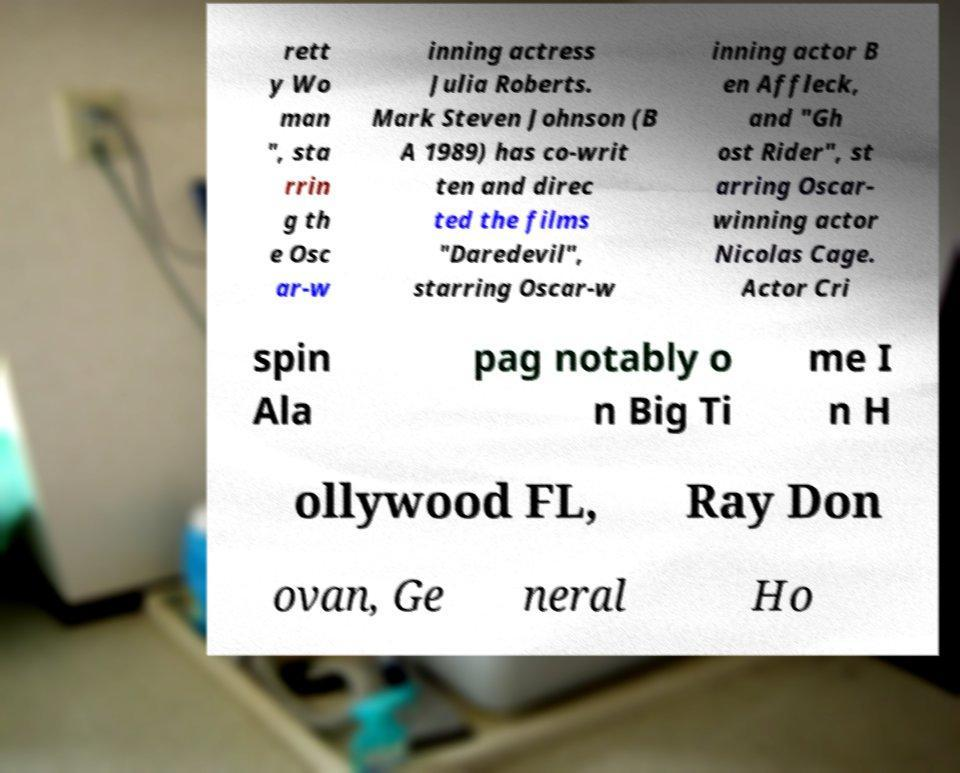Can you read and provide the text displayed in the image?This photo seems to have some interesting text. Can you extract and type it out for me? rett y Wo man ", sta rrin g th e Osc ar-w inning actress Julia Roberts. Mark Steven Johnson (B A 1989) has co-writ ten and direc ted the films "Daredevil", starring Oscar-w inning actor B en Affleck, and "Gh ost Rider", st arring Oscar- winning actor Nicolas Cage. Actor Cri spin Ala pag notably o n Big Ti me I n H ollywood FL, Ray Don ovan, Ge neral Ho 